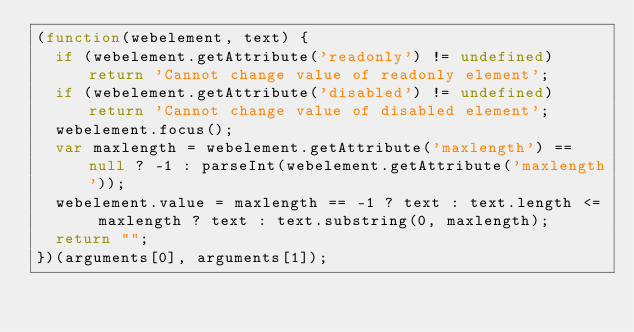Convert code to text. <code><loc_0><loc_0><loc_500><loc_500><_JavaScript_>(function(webelement, text) {
  if (webelement.getAttribute('readonly') != undefined) return 'Cannot change value of readonly element';
  if (webelement.getAttribute('disabled') != undefined) return 'Cannot change value of disabled element';
  webelement.focus();
  var maxlength = webelement.getAttribute('maxlength') == null ? -1 : parseInt(webelement.getAttribute('maxlength'));
  webelement.value = maxlength == -1 ? text : text.length <= maxlength ? text : text.substring(0, maxlength);
  return "";
})(arguments[0], arguments[1]);

</code> 